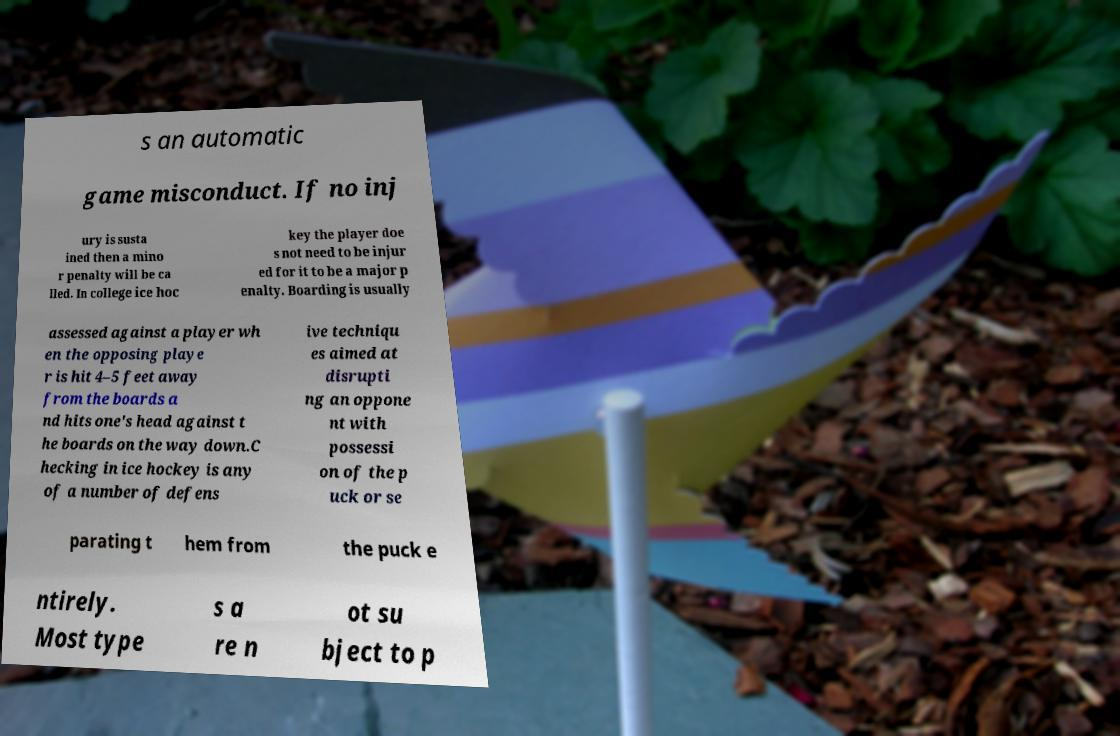There's text embedded in this image that I need extracted. Can you transcribe it verbatim? s an automatic game misconduct. If no inj ury is susta ined then a mino r penalty will be ca lled. In college ice hoc key the player doe s not need to be injur ed for it to be a major p enalty. Boarding is usually assessed against a player wh en the opposing playe r is hit 4–5 feet away from the boards a nd hits one's head against t he boards on the way down.C hecking in ice hockey is any of a number of defens ive techniqu es aimed at disrupti ng an oppone nt with possessi on of the p uck or se parating t hem from the puck e ntirely. Most type s a re n ot su bject to p 